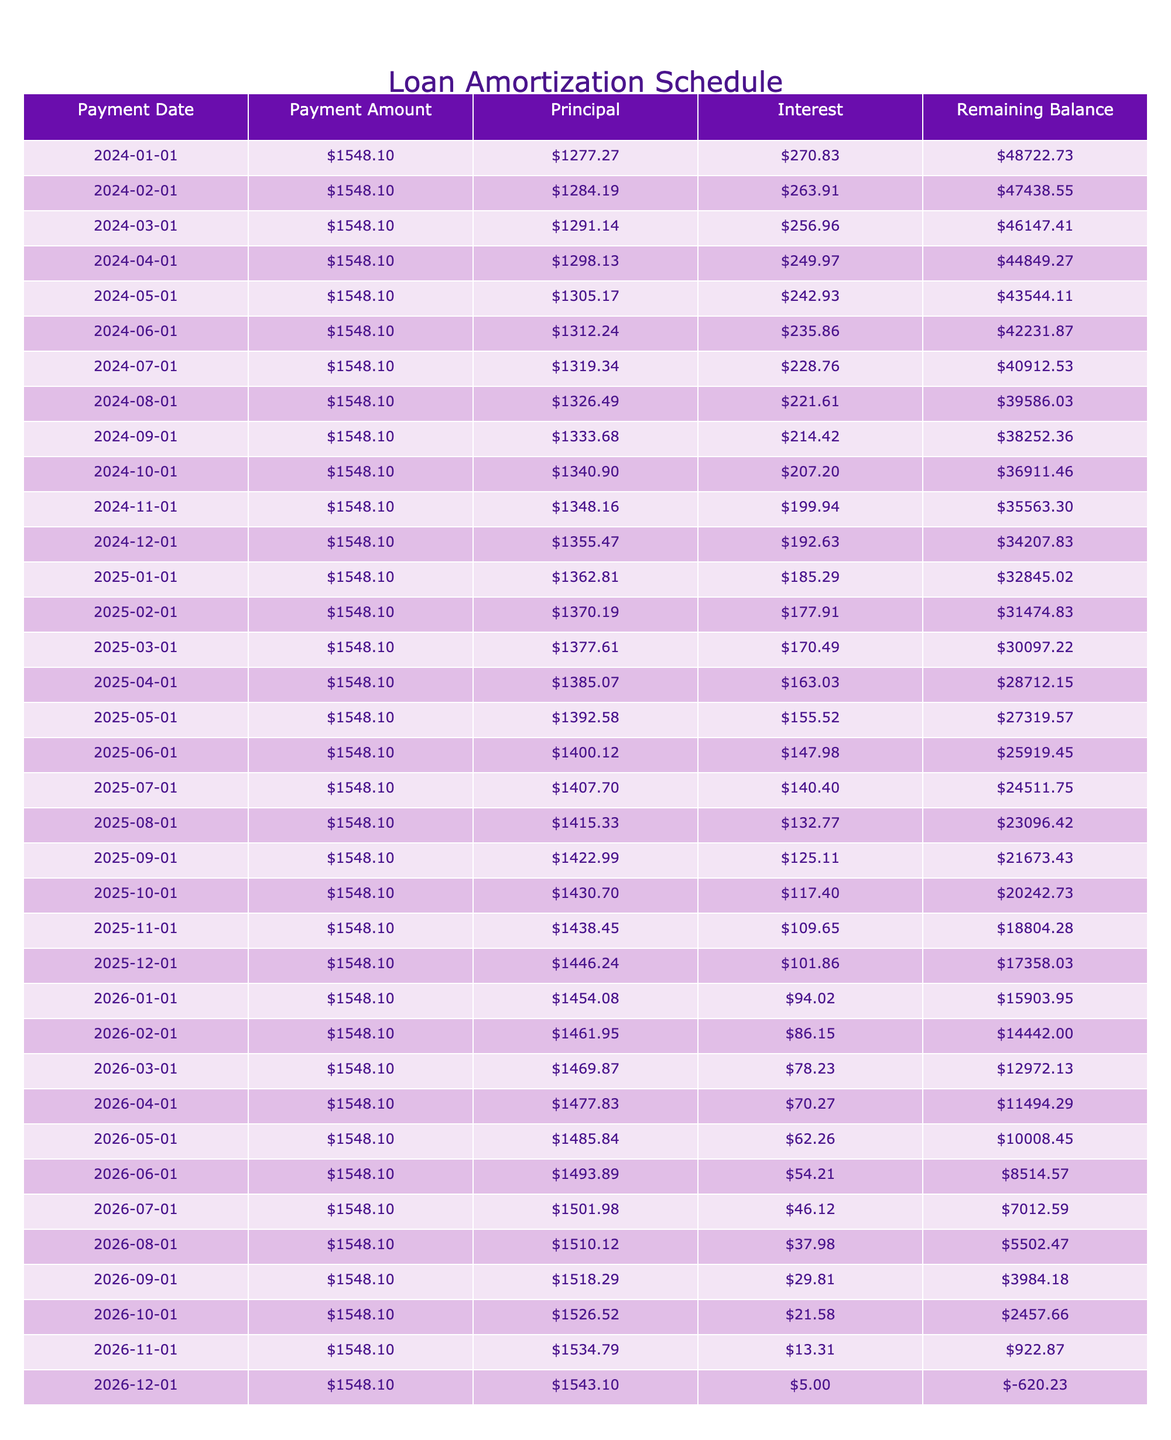What is the total payment amount over the loan term? The total payment amount is stated in the table, which is $55,613.60. This represents the total amount paid over the life of the loan, including both principal and interest payments.
Answer: $55,613.60 How much is the monthly payment? The monthly payment is clearly indicated in the table as $1,548.10, which is the amount that will be paid each month for the duration of the loan term.
Answer: $1,548.10 What is the total interest paid by the end of the loan? The total interest paid is given in the table as $5,613.60. This represents the amount that will be paid in addition to the principal loan amount over the course of the loan.
Answer: $5,613.60 Is the loan term longer than two years? The loan term is 36 months, which is equivalent to 3 years. Since 3 years is longer than 2 years, the statement is true.
Answer: Yes What is the remaining balance after the first month? The remaining balance after the first month is calculated by taking the loan amount of $50,000 and subtracting the principal payment made in the first month. The principal payment is found by subtracting the interest payment from the monthly payment. The interest payment for the first month is $270.83 (calculated from the loan amount and interest rate), so the principal payment is $1,548.10 - $270.83 = $1,277.27. Thus, the remaining balance after the first month is $50,000 - $1,277.27 = $48,722.73.
Answer: $48,722.73 What is the ratio of total interest to total payment? To find the ratio of total interest to total payment, divide the total interest amount of $5,613.60 by the total payment amount of $55,613.60. So, the ratio is $5,613.60 / $55,613.60, which equals approximately 0.101, or 10.1%.
Answer: 10.1% 